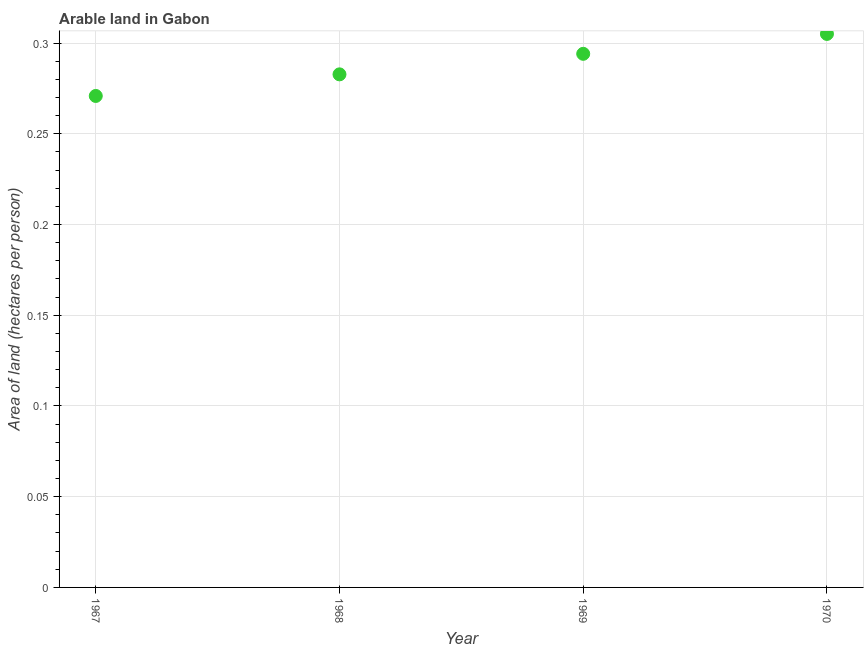What is the area of arable land in 1969?
Your answer should be very brief. 0.29. Across all years, what is the maximum area of arable land?
Your response must be concise. 0.31. Across all years, what is the minimum area of arable land?
Provide a succinct answer. 0.27. In which year was the area of arable land minimum?
Your response must be concise. 1967. What is the sum of the area of arable land?
Provide a succinct answer. 1.15. What is the difference between the area of arable land in 1967 and 1969?
Keep it short and to the point. -0.02. What is the average area of arable land per year?
Your answer should be compact. 0.29. What is the median area of arable land?
Keep it short and to the point. 0.29. What is the ratio of the area of arable land in 1969 to that in 1970?
Ensure brevity in your answer.  0.96. Is the area of arable land in 1967 less than that in 1969?
Provide a short and direct response. Yes. Is the difference between the area of arable land in 1967 and 1968 greater than the difference between any two years?
Your answer should be very brief. No. What is the difference between the highest and the second highest area of arable land?
Provide a succinct answer. 0.01. What is the difference between the highest and the lowest area of arable land?
Your response must be concise. 0.03. In how many years, is the area of arable land greater than the average area of arable land taken over all years?
Ensure brevity in your answer.  2. How many dotlines are there?
Make the answer very short. 1. Does the graph contain any zero values?
Your answer should be very brief. No. Does the graph contain grids?
Provide a short and direct response. Yes. What is the title of the graph?
Your answer should be very brief. Arable land in Gabon. What is the label or title of the Y-axis?
Your answer should be compact. Area of land (hectares per person). What is the Area of land (hectares per person) in 1967?
Make the answer very short. 0.27. What is the Area of land (hectares per person) in 1968?
Provide a succinct answer. 0.28. What is the Area of land (hectares per person) in 1969?
Provide a succinct answer. 0.29. What is the Area of land (hectares per person) in 1970?
Offer a very short reply. 0.31. What is the difference between the Area of land (hectares per person) in 1967 and 1968?
Provide a short and direct response. -0.01. What is the difference between the Area of land (hectares per person) in 1967 and 1969?
Offer a terse response. -0.02. What is the difference between the Area of land (hectares per person) in 1967 and 1970?
Your answer should be compact. -0.03. What is the difference between the Area of land (hectares per person) in 1968 and 1969?
Your answer should be very brief. -0.01. What is the difference between the Area of land (hectares per person) in 1968 and 1970?
Ensure brevity in your answer.  -0.02. What is the difference between the Area of land (hectares per person) in 1969 and 1970?
Ensure brevity in your answer.  -0.01. What is the ratio of the Area of land (hectares per person) in 1967 to that in 1968?
Ensure brevity in your answer.  0.96. What is the ratio of the Area of land (hectares per person) in 1967 to that in 1969?
Make the answer very short. 0.92. What is the ratio of the Area of land (hectares per person) in 1967 to that in 1970?
Make the answer very short. 0.89. What is the ratio of the Area of land (hectares per person) in 1968 to that in 1970?
Make the answer very short. 0.93. What is the ratio of the Area of land (hectares per person) in 1969 to that in 1970?
Keep it short and to the point. 0.96. 